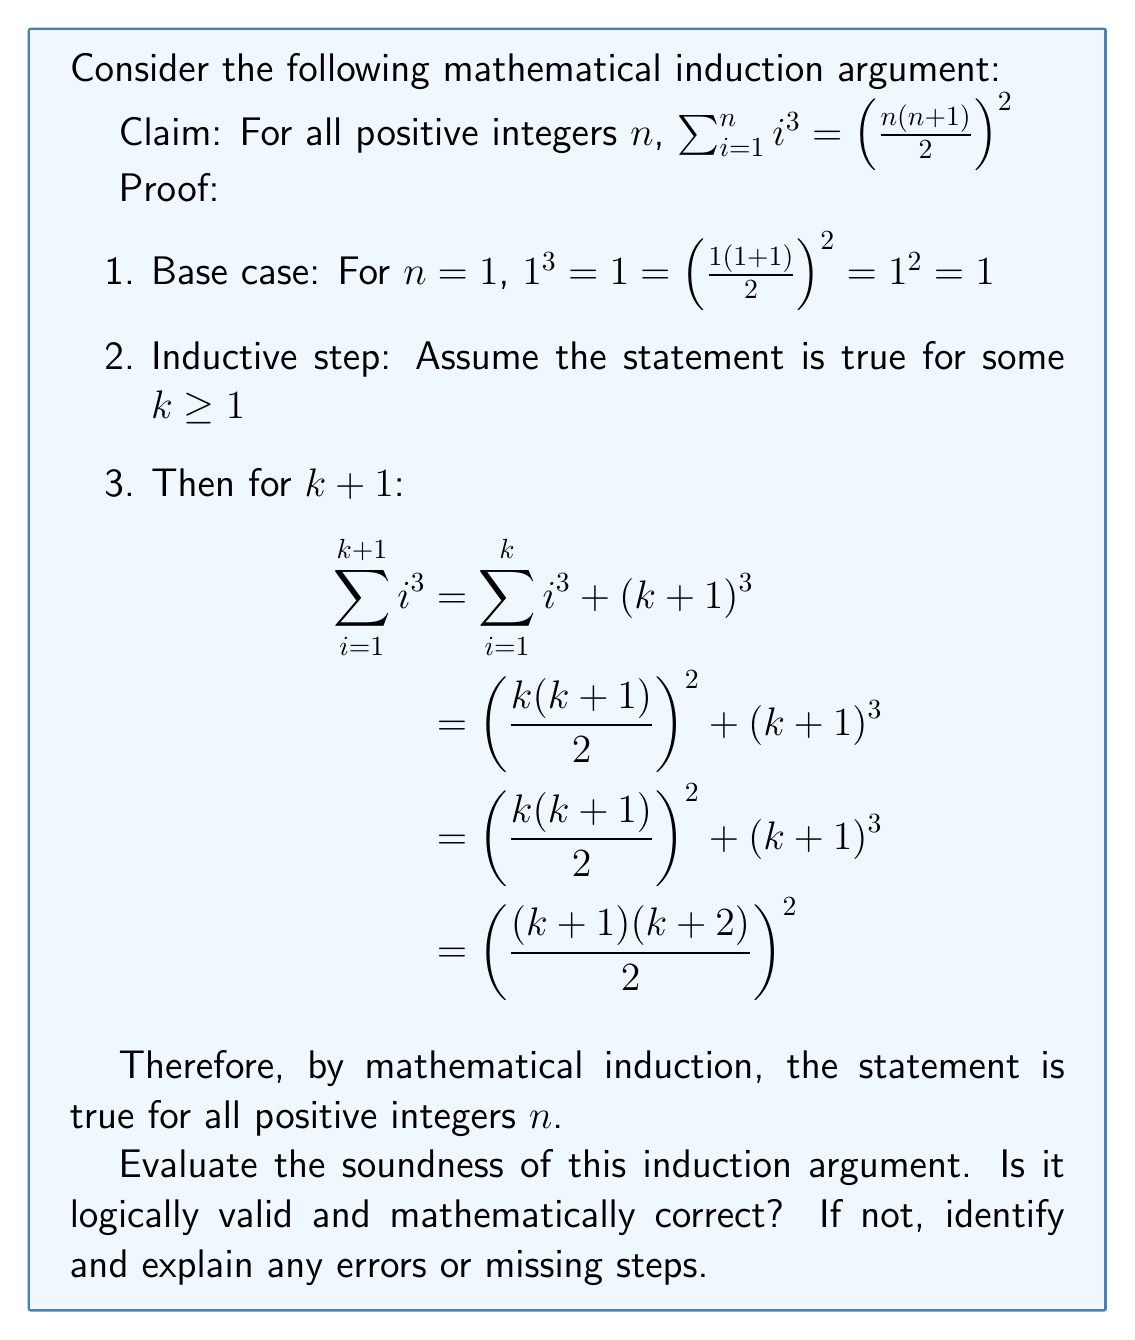Could you help me with this problem? To evaluate the soundness of this mathematical induction argument, we need to examine each step carefully:

1. Base case: The base case for $n=1$ is correct. $1^3 = 1 = (\frac{1(1+1)}{2})^2 = 1^2 = 1$

2. Inductive hypothesis: The assumption that the statement is true for some $k \geq 1$ is correctly stated.

3. Inductive step: This is where we need to pay close attention.

   a) The first line is correct: $\sum_{i=1}^{k+1} i^3 = \sum_{i=1}^k i^3 + (k+1)^3$

   b) The second line correctly applies the inductive hypothesis:
      $= (\frac{k(k+1)}{2})^2 + (k+1)^3$

   c) The third line is redundant as it's the same as the second line.

   d) The fourth line is where the error occurs. The proof jumps directly to the conclusion without showing the algebraic steps to get there. This is a significant gap in the proof.

To fix this, we need to show the algebraic manipulation from step (b) to the final result:

$(\frac{k(k+1)}{2})^2 + (k+1)^3$
$= \frac{k^2(k+1)^2}{4} + (k+1)^3$
$= \frac{k^2(k+1)^2 + 4(k+1)^3}{4}$
$= \frac{(k+1)^2(k^2 + 4k + 4)}{4}$
$= \frac{(k+1)^2(k+2)^2}{4}$
$= (\frac{(k+1)(k+2)}{2})^2$

This shows that the statement is indeed true for $k+1$ if it's true for $k$.

4. Conclusion: The conclusion is correct, but it relies on the complete proof of the inductive step, which was missing in the original argument.

In summary, while the overall structure of the induction argument is correct, the crucial algebraic steps in the inductive step were omitted, which is a significant flaw in the proof. A mathematically sound induction argument should include all necessary steps to demonstrate how the statement for $k$ leads to the statement for $k+1$.
Answer: The induction argument is logically valid but mathematically incomplete. The proof structure is correct, but it lacks the crucial algebraic steps in the inductive step to show how $(\frac{k(k+1)}{2})^2 + (k+1)^3$ equals $(\frac{(k+1)(k+2)}{2})^2$. To be considered sound and complete, the proof should include these missing algebraic manipulations. 